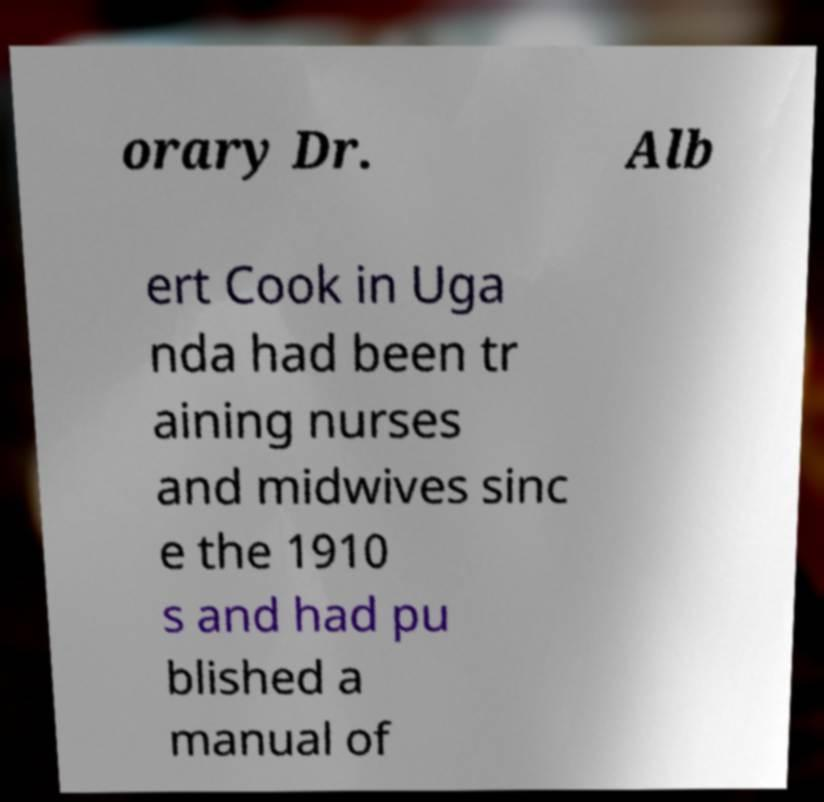Could you assist in decoding the text presented in this image and type it out clearly? orary Dr. Alb ert Cook in Uga nda had been tr aining nurses and midwives sinc e the 1910 s and had pu blished a manual of 